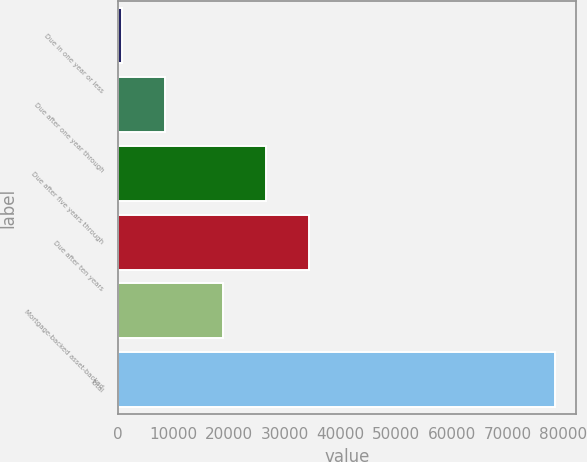<chart> <loc_0><loc_0><loc_500><loc_500><bar_chart><fcel>Due in one year or less<fcel>Due after one year through<fcel>Due after five years through<fcel>Due after ten years<fcel>Mortgage-backed asset-backed<fcel>Total<nl><fcel>739<fcel>8511.1<fcel>26605.1<fcel>34377.2<fcel>18833<fcel>78460<nl></chart> 